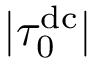<formula> <loc_0><loc_0><loc_500><loc_500>| \tau _ { 0 } ^ { d c } |</formula> 